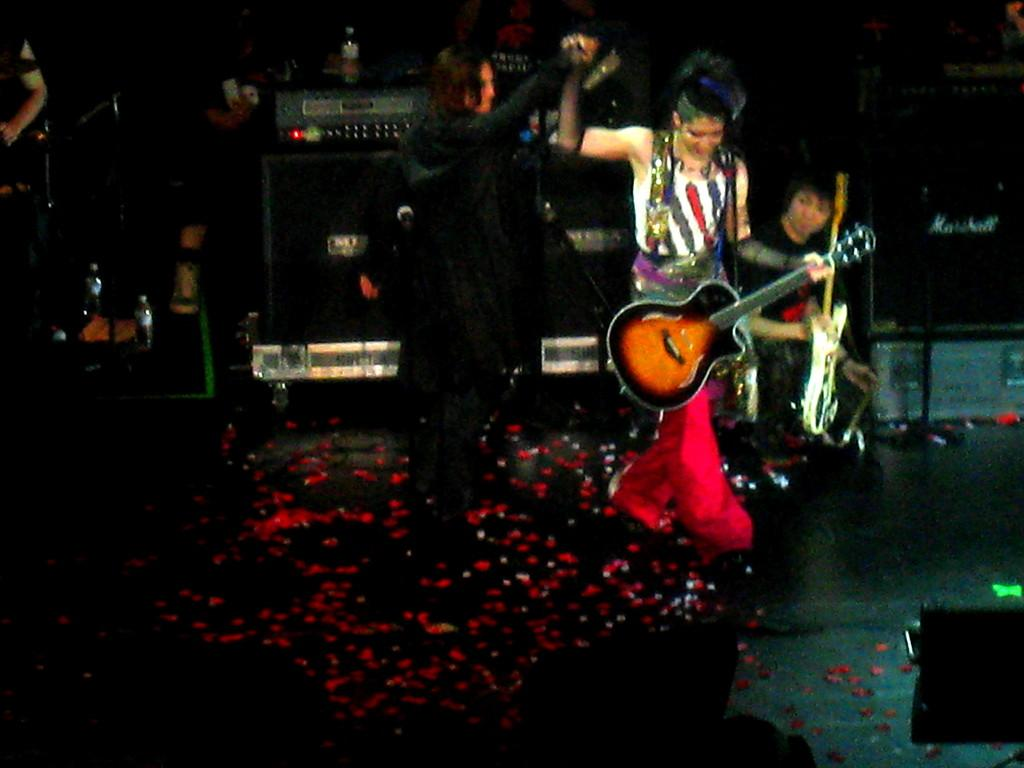Who are the people in the image? There is a man and a woman in the image. What is the man doing in the image? The man is holding a musical instrument and dancing. What can be seen in the background of the image? There are musical instruments in the background of the image. What is the temperature of the hot beverage being served by the man's uncle in the image? There is no uncle or hot beverage present in the image. 